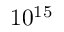<formula> <loc_0><loc_0><loc_500><loc_500>1 0 ^ { 1 5 }</formula> 